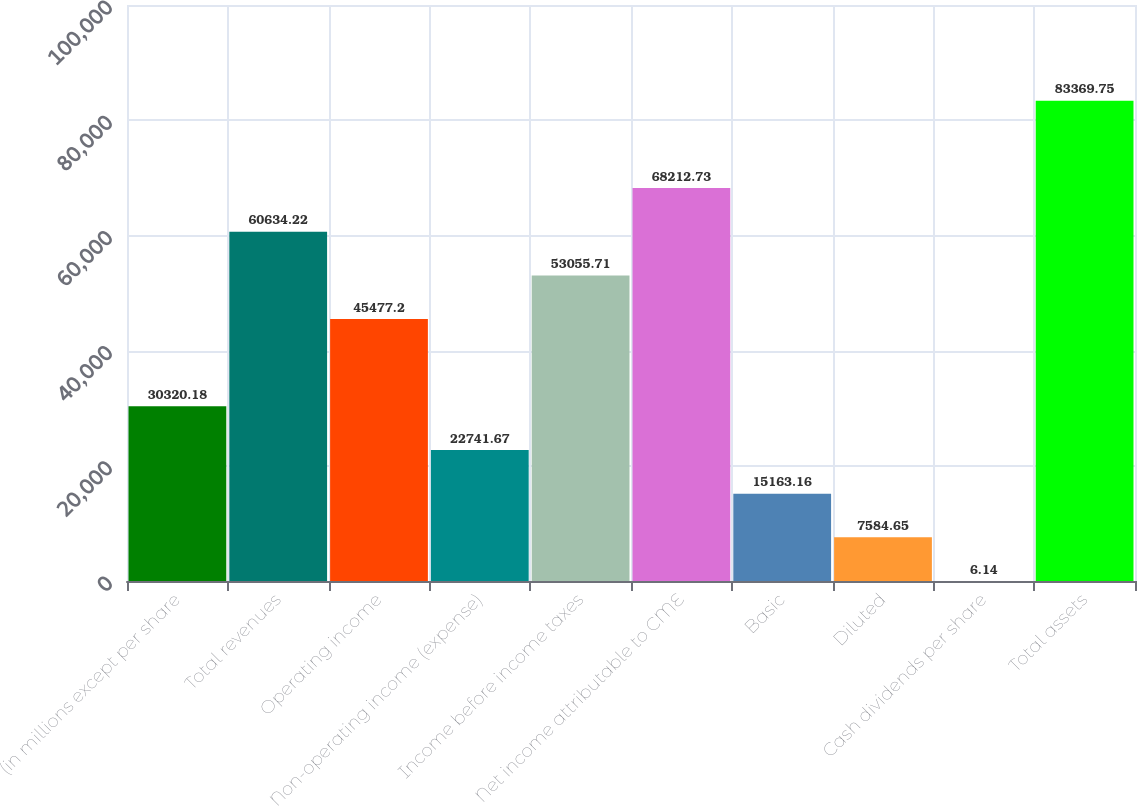Convert chart. <chart><loc_0><loc_0><loc_500><loc_500><bar_chart><fcel>(in millions except per share<fcel>Total revenues<fcel>Operating income<fcel>Non-operating income (expense)<fcel>Income before income taxes<fcel>Net income attributable to CME<fcel>Basic<fcel>Diluted<fcel>Cash dividends per share<fcel>Total assets<nl><fcel>30320.2<fcel>60634.2<fcel>45477.2<fcel>22741.7<fcel>53055.7<fcel>68212.7<fcel>15163.2<fcel>7584.65<fcel>6.14<fcel>83369.8<nl></chart> 